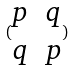Convert formula to latex. <formula><loc_0><loc_0><loc_500><loc_500>( \begin{matrix} p & q \\ q & p \end{matrix} )</formula> 